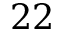<formula> <loc_0><loc_0><loc_500><loc_500>2 2</formula> 